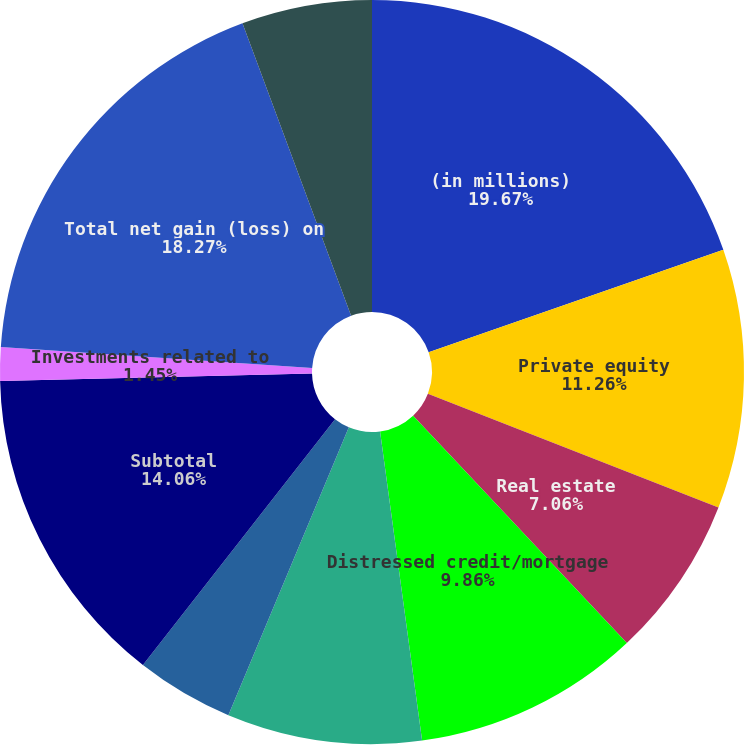<chart> <loc_0><loc_0><loc_500><loc_500><pie_chart><fcel>(in millions)<fcel>Private equity<fcel>Real estate<fcel>Distressed credit/mortgage<fcel>Hedge funds/funds of hedge<fcel>Other investments (2)<fcel>Subtotal<fcel>Investments related to<fcel>Total net gain (loss) on<fcel>Interest and dividend income<nl><fcel>19.67%<fcel>11.26%<fcel>7.06%<fcel>9.86%<fcel>8.46%<fcel>4.25%<fcel>14.06%<fcel>1.45%<fcel>18.27%<fcel>5.66%<nl></chart> 